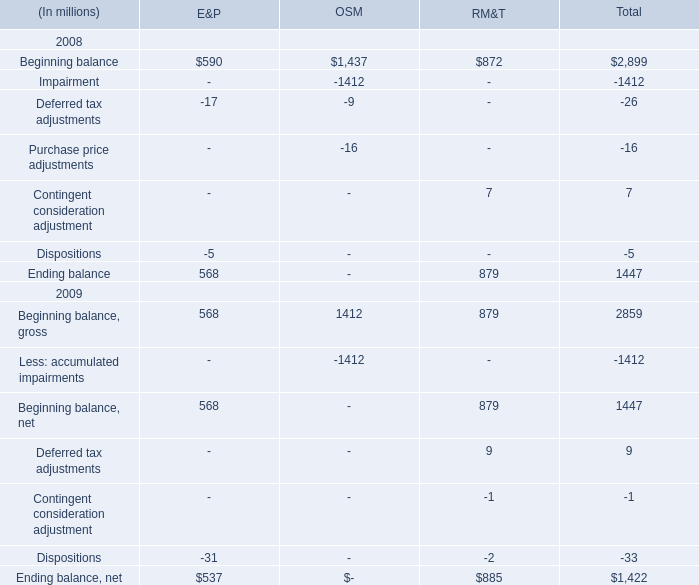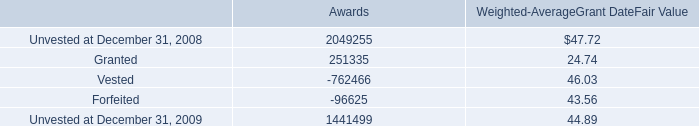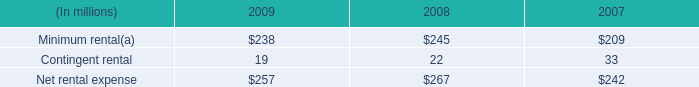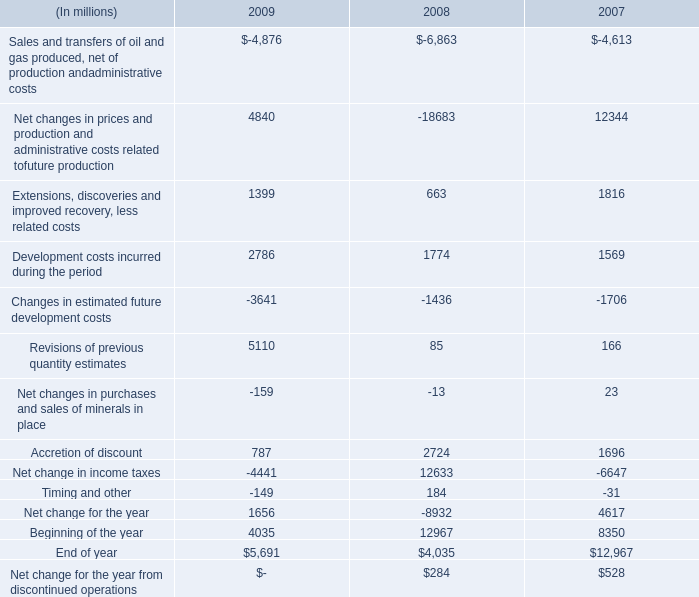What is the sum of the Ending balance in the years where Beginning balance for RM&T greater than 878? (in million) 
Computations: (537 + 885)
Answer: 1422.0. 